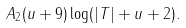Convert formula to latex. <formula><loc_0><loc_0><loc_500><loc_500>A _ { 2 } ( u + 9 ) \log ( | T | + u + 2 ) .</formula> 